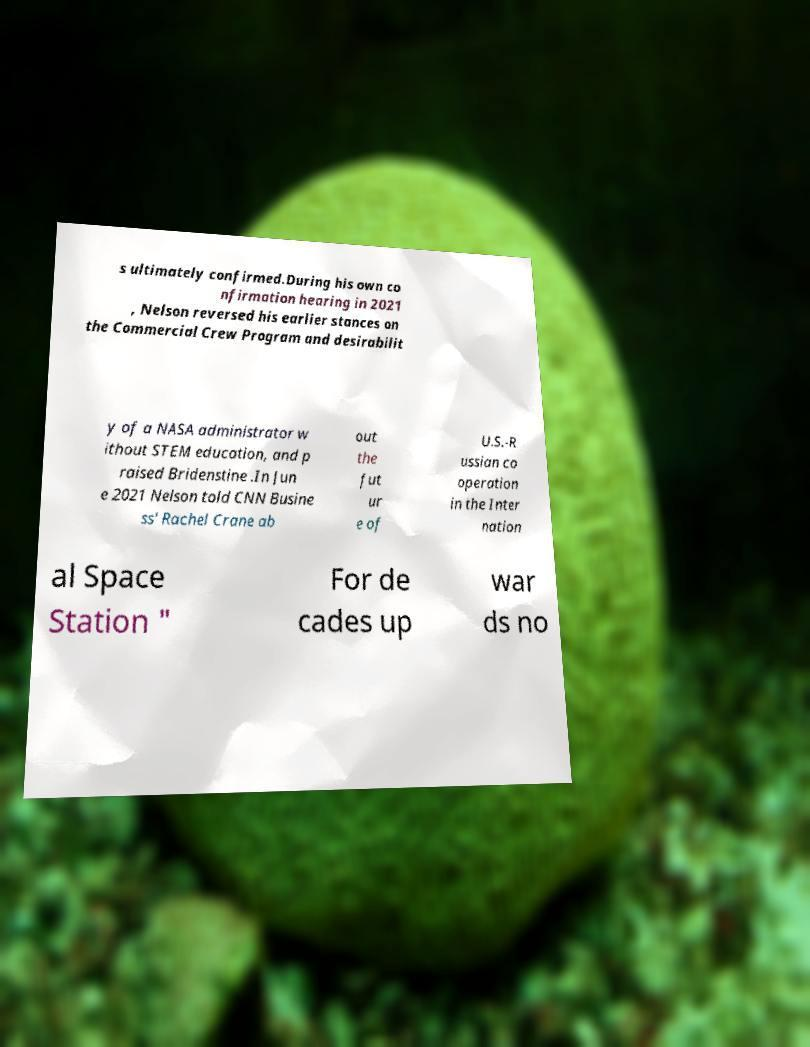There's text embedded in this image that I need extracted. Can you transcribe it verbatim? s ultimately confirmed.During his own co nfirmation hearing in 2021 , Nelson reversed his earlier stances on the Commercial Crew Program and desirabilit y of a NASA administrator w ithout STEM education, and p raised Bridenstine .In Jun e 2021 Nelson told CNN Busine ss' Rachel Crane ab out the fut ur e of U.S.-R ussian co operation in the Inter nation al Space Station " For de cades up war ds no 